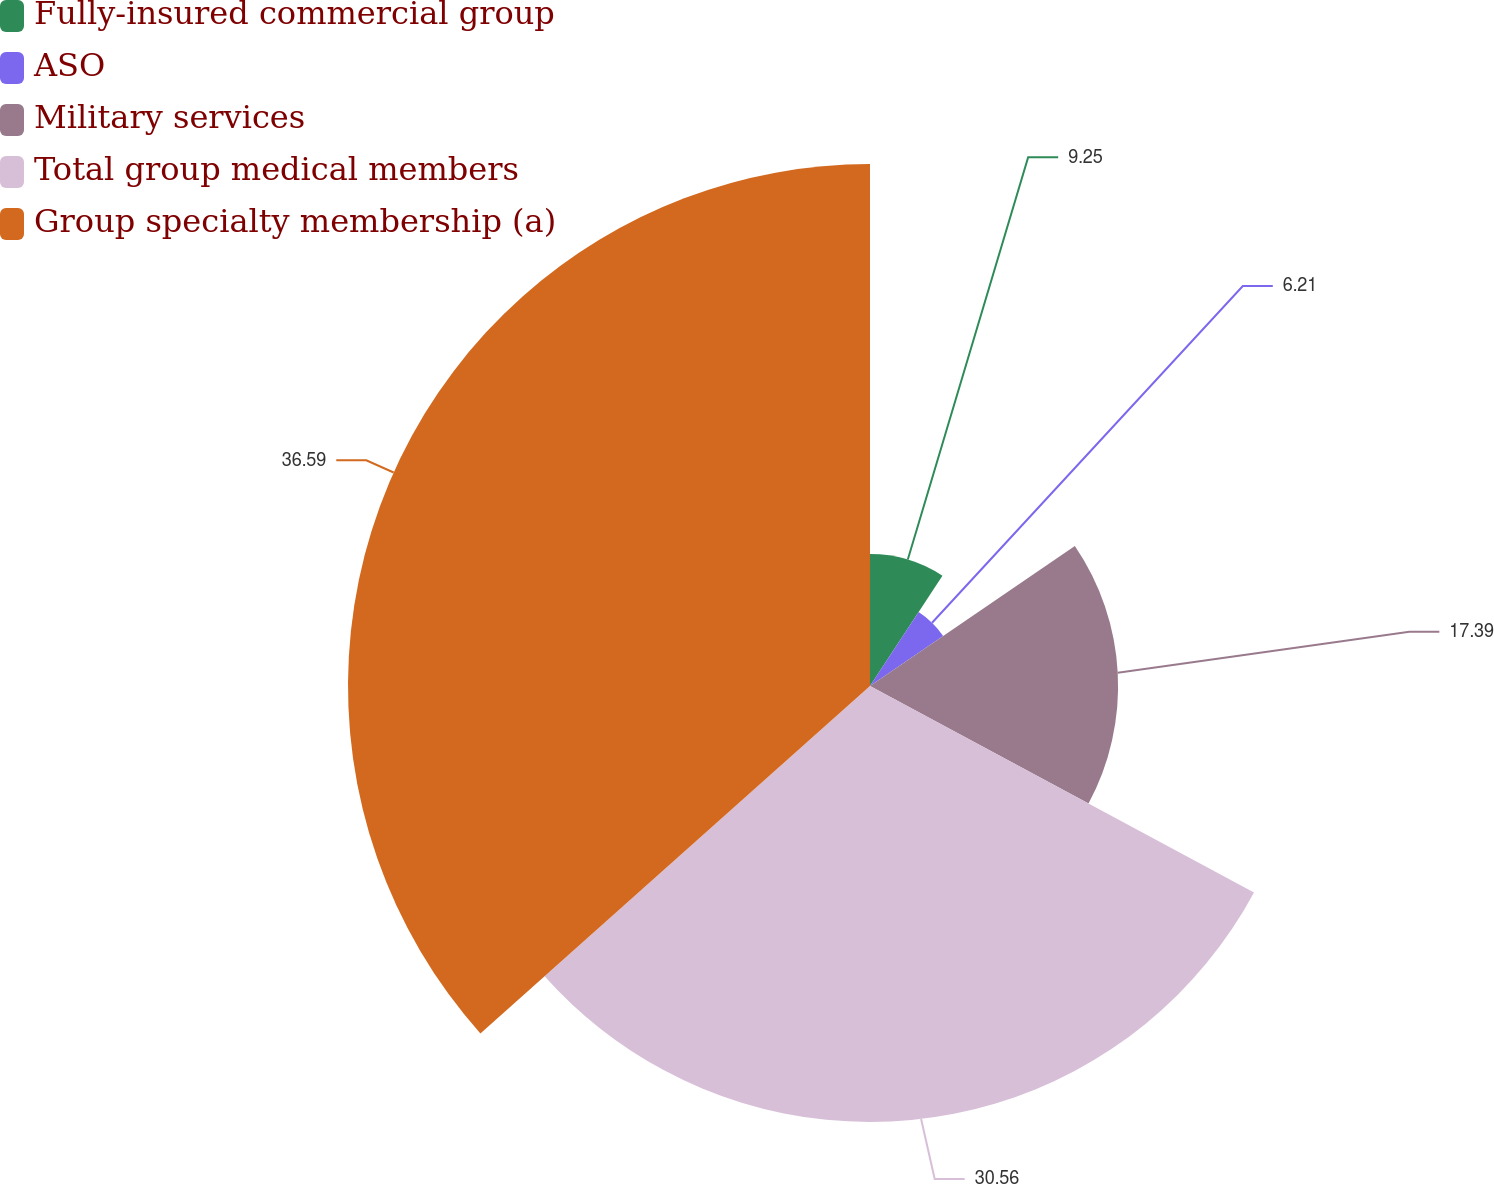Convert chart. <chart><loc_0><loc_0><loc_500><loc_500><pie_chart><fcel>Fully-insured commercial group<fcel>ASO<fcel>Military services<fcel>Total group medical members<fcel>Group specialty membership (a)<nl><fcel>9.25%<fcel>6.21%<fcel>17.39%<fcel>30.56%<fcel>36.59%<nl></chart> 